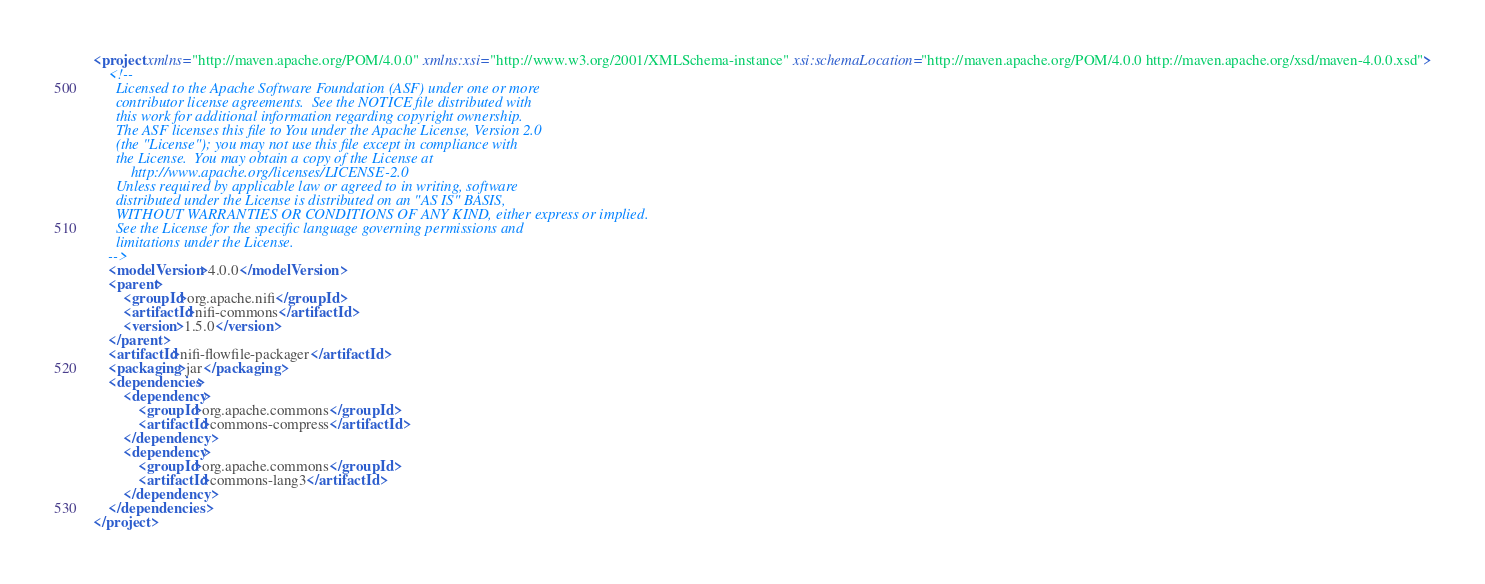Convert code to text. <code><loc_0><loc_0><loc_500><loc_500><_XML_><project xmlns="http://maven.apache.org/POM/4.0.0" xmlns:xsi="http://www.w3.org/2001/XMLSchema-instance" xsi:schemaLocation="http://maven.apache.org/POM/4.0.0 http://maven.apache.org/xsd/maven-4.0.0.xsd">
    <!--
      Licensed to the Apache Software Foundation (ASF) under one or more
      contributor license agreements.  See the NOTICE file distributed with
      this work for additional information regarding copyright ownership.
      The ASF licenses this file to You under the Apache License, Version 2.0
      (the "License"); you may not use this file except in compliance with
      the License.  You may obtain a copy of the License at
          http://www.apache.org/licenses/LICENSE-2.0
      Unless required by applicable law or agreed to in writing, software
      distributed under the License is distributed on an "AS IS" BASIS,
      WITHOUT WARRANTIES OR CONDITIONS OF ANY KIND, either express or implied.
      See the License for the specific language governing permissions and
      limitations under the License.
    -->
    <modelVersion>4.0.0</modelVersion>
    <parent>
        <groupId>org.apache.nifi</groupId>
        <artifactId>nifi-commons</artifactId>
        <version>1.5.0</version>
    </parent>
    <artifactId>nifi-flowfile-packager</artifactId>
    <packaging>jar</packaging>
    <dependencies>
        <dependency>
            <groupId>org.apache.commons</groupId>
            <artifactId>commons-compress</artifactId>
        </dependency>
        <dependency>
            <groupId>org.apache.commons</groupId>
            <artifactId>commons-lang3</artifactId>
        </dependency>
    </dependencies>
</project>
</code> 